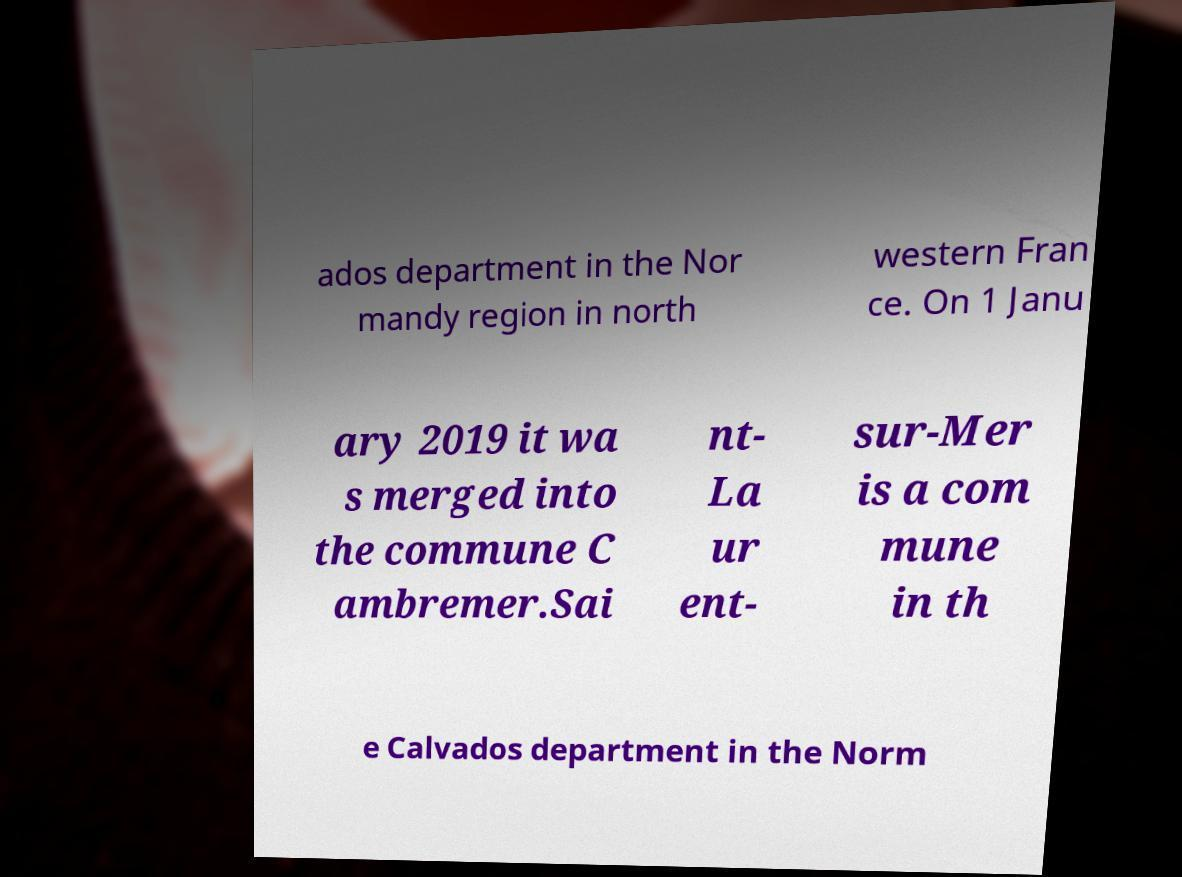What messages or text are displayed in this image? I need them in a readable, typed format. ados department in the Nor mandy region in north western Fran ce. On 1 Janu ary 2019 it wa s merged into the commune C ambremer.Sai nt- La ur ent- sur-Mer is a com mune in th e Calvados department in the Norm 